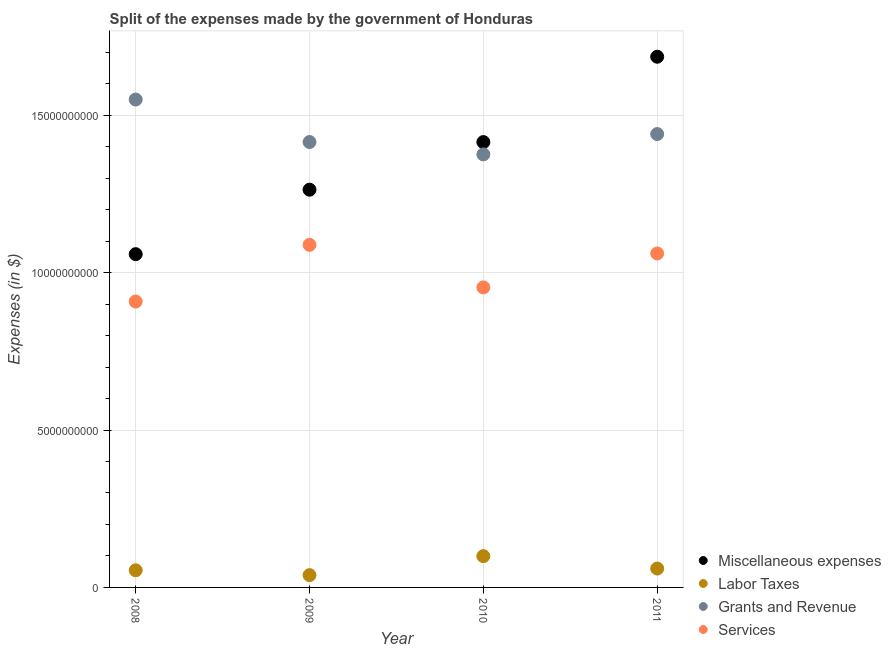How many different coloured dotlines are there?
Your response must be concise. 4. Is the number of dotlines equal to the number of legend labels?
Ensure brevity in your answer.  Yes. What is the amount spent on miscellaneous expenses in 2010?
Your answer should be compact. 1.41e+1. Across all years, what is the maximum amount spent on services?
Make the answer very short. 1.09e+1. Across all years, what is the minimum amount spent on grants and revenue?
Provide a short and direct response. 1.38e+1. What is the total amount spent on labor taxes in the graph?
Ensure brevity in your answer.  2.53e+09. What is the difference between the amount spent on miscellaneous expenses in 2010 and that in 2011?
Your answer should be compact. -2.71e+09. What is the difference between the amount spent on miscellaneous expenses in 2011 and the amount spent on grants and revenue in 2008?
Your response must be concise. 1.36e+09. What is the average amount spent on services per year?
Offer a very short reply. 1.00e+1. In the year 2008, what is the difference between the amount spent on services and amount spent on labor taxes?
Provide a short and direct response. 8.54e+09. In how many years, is the amount spent on labor taxes greater than 2000000000 $?
Your answer should be compact. 0. What is the ratio of the amount spent on grants and revenue in 2008 to that in 2010?
Your answer should be very brief. 1.13. Is the difference between the amount spent on labor taxes in 2009 and 2011 greater than the difference between the amount spent on services in 2009 and 2011?
Your answer should be compact. No. What is the difference between the highest and the second highest amount spent on miscellaneous expenses?
Provide a succinct answer. 2.71e+09. What is the difference between the highest and the lowest amount spent on labor taxes?
Provide a short and direct response. 6.03e+08. Does the amount spent on grants and revenue monotonically increase over the years?
Provide a succinct answer. No. How many dotlines are there?
Your answer should be very brief. 4. How many years are there in the graph?
Offer a terse response. 4. Are the values on the major ticks of Y-axis written in scientific E-notation?
Provide a short and direct response. No. How are the legend labels stacked?
Offer a very short reply. Vertical. What is the title of the graph?
Ensure brevity in your answer.  Split of the expenses made by the government of Honduras. Does "Social Assistance" appear as one of the legend labels in the graph?
Provide a short and direct response. No. What is the label or title of the X-axis?
Your answer should be very brief. Year. What is the label or title of the Y-axis?
Your response must be concise. Expenses (in $). What is the Expenses (in $) in Miscellaneous expenses in 2008?
Ensure brevity in your answer.  1.06e+1. What is the Expenses (in $) in Labor Taxes in 2008?
Keep it short and to the point. 5.44e+08. What is the Expenses (in $) in Grants and Revenue in 2008?
Ensure brevity in your answer.  1.55e+1. What is the Expenses (in $) in Services in 2008?
Give a very brief answer. 9.08e+09. What is the Expenses (in $) of Miscellaneous expenses in 2009?
Your response must be concise. 1.26e+1. What is the Expenses (in $) of Labor Taxes in 2009?
Give a very brief answer. 3.91e+08. What is the Expenses (in $) of Grants and Revenue in 2009?
Offer a very short reply. 1.41e+1. What is the Expenses (in $) of Services in 2009?
Provide a succinct answer. 1.09e+1. What is the Expenses (in $) in Miscellaneous expenses in 2010?
Make the answer very short. 1.41e+1. What is the Expenses (in $) in Labor Taxes in 2010?
Give a very brief answer. 9.94e+08. What is the Expenses (in $) in Grants and Revenue in 2010?
Ensure brevity in your answer.  1.38e+1. What is the Expenses (in $) in Services in 2010?
Your answer should be very brief. 9.53e+09. What is the Expenses (in $) in Miscellaneous expenses in 2011?
Offer a very short reply. 1.69e+1. What is the Expenses (in $) in Labor Taxes in 2011?
Your answer should be compact. 6.00e+08. What is the Expenses (in $) of Grants and Revenue in 2011?
Offer a terse response. 1.44e+1. What is the Expenses (in $) of Services in 2011?
Make the answer very short. 1.06e+1. Across all years, what is the maximum Expenses (in $) in Miscellaneous expenses?
Provide a succinct answer. 1.69e+1. Across all years, what is the maximum Expenses (in $) in Labor Taxes?
Keep it short and to the point. 9.94e+08. Across all years, what is the maximum Expenses (in $) of Grants and Revenue?
Your answer should be very brief. 1.55e+1. Across all years, what is the maximum Expenses (in $) of Services?
Provide a short and direct response. 1.09e+1. Across all years, what is the minimum Expenses (in $) of Miscellaneous expenses?
Your answer should be compact. 1.06e+1. Across all years, what is the minimum Expenses (in $) in Labor Taxes?
Your answer should be very brief. 3.91e+08. Across all years, what is the minimum Expenses (in $) of Grants and Revenue?
Offer a very short reply. 1.38e+1. Across all years, what is the minimum Expenses (in $) of Services?
Provide a short and direct response. 9.08e+09. What is the total Expenses (in $) of Miscellaneous expenses in the graph?
Provide a succinct answer. 5.42e+1. What is the total Expenses (in $) of Labor Taxes in the graph?
Offer a very short reply. 2.53e+09. What is the total Expenses (in $) in Grants and Revenue in the graph?
Provide a succinct answer. 5.78e+1. What is the total Expenses (in $) of Services in the graph?
Provide a succinct answer. 4.01e+1. What is the difference between the Expenses (in $) in Miscellaneous expenses in 2008 and that in 2009?
Offer a terse response. -2.05e+09. What is the difference between the Expenses (in $) of Labor Taxes in 2008 and that in 2009?
Provide a short and direct response. 1.53e+08. What is the difference between the Expenses (in $) of Grants and Revenue in 2008 and that in 2009?
Make the answer very short. 1.35e+09. What is the difference between the Expenses (in $) of Services in 2008 and that in 2009?
Your answer should be very brief. -1.80e+09. What is the difference between the Expenses (in $) of Miscellaneous expenses in 2008 and that in 2010?
Provide a succinct answer. -3.56e+09. What is the difference between the Expenses (in $) in Labor Taxes in 2008 and that in 2010?
Keep it short and to the point. -4.50e+08. What is the difference between the Expenses (in $) in Grants and Revenue in 2008 and that in 2010?
Provide a short and direct response. 1.74e+09. What is the difference between the Expenses (in $) of Services in 2008 and that in 2010?
Provide a short and direct response. -4.48e+08. What is the difference between the Expenses (in $) of Miscellaneous expenses in 2008 and that in 2011?
Offer a terse response. -6.27e+09. What is the difference between the Expenses (in $) in Labor Taxes in 2008 and that in 2011?
Give a very brief answer. -5.59e+07. What is the difference between the Expenses (in $) of Grants and Revenue in 2008 and that in 2011?
Keep it short and to the point. 1.10e+09. What is the difference between the Expenses (in $) of Services in 2008 and that in 2011?
Your answer should be compact. -1.53e+09. What is the difference between the Expenses (in $) in Miscellaneous expenses in 2009 and that in 2010?
Your response must be concise. -1.51e+09. What is the difference between the Expenses (in $) of Labor Taxes in 2009 and that in 2010?
Provide a short and direct response. -6.03e+08. What is the difference between the Expenses (in $) in Grants and Revenue in 2009 and that in 2010?
Provide a succinct answer. 3.92e+08. What is the difference between the Expenses (in $) of Services in 2009 and that in 2010?
Your response must be concise. 1.35e+09. What is the difference between the Expenses (in $) of Miscellaneous expenses in 2009 and that in 2011?
Offer a very short reply. -4.22e+09. What is the difference between the Expenses (in $) in Labor Taxes in 2009 and that in 2011?
Provide a short and direct response. -2.09e+08. What is the difference between the Expenses (in $) of Grants and Revenue in 2009 and that in 2011?
Offer a very short reply. -2.53e+08. What is the difference between the Expenses (in $) in Services in 2009 and that in 2011?
Offer a terse response. 2.73e+08. What is the difference between the Expenses (in $) of Miscellaneous expenses in 2010 and that in 2011?
Your answer should be very brief. -2.71e+09. What is the difference between the Expenses (in $) of Labor Taxes in 2010 and that in 2011?
Ensure brevity in your answer.  3.94e+08. What is the difference between the Expenses (in $) of Grants and Revenue in 2010 and that in 2011?
Give a very brief answer. -6.45e+08. What is the difference between the Expenses (in $) of Services in 2010 and that in 2011?
Make the answer very short. -1.08e+09. What is the difference between the Expenses (in $) of Miscellaneous expenses in 2008 and the Expenses (in $) of Labor Taxes in 2009?
Give a very brief answer. 1.02e+1. What is the difference between the Expenses (in $) in Miscellaneous expenses in 2008 and the Expenses (in $) in Grants and Revenue in 2009?
Your answer should be compact. -3.56e+09. What is the difference between the Expenses (in $) in Miscellaneous expenses in 2008 and the Expenses (in $) in Services in 2009?
Offer a terse response. -2.95e+08. What is the difference between the Expenses (in $) in Labor Taxes in 2008 and the Expenses (in $) in Grants and Revenue in 2009?
Give a very brief answer. -1.36e+1. What is the difference between the Expenses (in $) in Labor Taxes in 2008 and the Expenses (in $) in Services in 2009?
Your answer should be very brief. -1.03e+1. What is the difference between the Expenses (in $) of Grants and Revenue in 2008 and the Expenses (in $) of Services in 2009?
Your answer should be compact. 4.62e+09. What is the difference between the Expenses (in $) of Miscellaneous expenses in 2008 and the Expenses (in $) of Labor Taxes in 2010?
Provide a short and direct response. 9.59e+09. What is the difference between the Expenses (in $) in Miscellaneous expenses in 2008 and the Expenses (in $) in Grants and Revenue in 2010?
Make the answer very short. -3.17e+09. What is the difference between the Expenses (in $) of Miscellaneous expenses in 2008 and the Expenses (in $) of Services in 2010?
Offer a terse response. 1.06e+09. What is the difference between the Expenses (in $) in Labor Taxes in 2008 and the Expenses (in $) in Grants and Revenue in 2010?
Your response must be concise. -1.32e+1. What is the difference between the Expenses (in $) of Labor Taxes in 2008 and the Expenses (in $) of Services in 2010?
Provide a succinct answer. -8.99e+09. What is the difference between the Expenses (in $) in Grants and Revenue in 2008 and the Expenses (in $) in Services in 2010?
Your answer should be compact. 5.97e+09. What is the difference between the Expenses (in $) of Miscellaneous expenses in 2008 and the Expenses (in $) of Labor Taxes in 2011?
Keep it short and to the point. 9.99e+09. What is the difference between the Expenses (in $) of Miscellaneous expenses in 2008 and the Expenses (in $) of Grants and Revenue in 2011?
Provide a short and direct response. -3.81e+09. What is the difference between the Expenses (in $) of Miscellaneous expenses in 2008 and the Expenses (in $) of Services in 2011?
Make the answer very short. -2.27e+07. What is the difference between the Expenses (in $) in Labor Taxes in 2008 and the Expenses (in $) in Grants and Revenue in 2011?
Your answer should be compact. -1.39e+1. What is the difference between the Expenses (in $) in Labor Taxes in 2008 and the Expenses (in $) in Services in 2011?
Provide a succinct answer. -1.01e+1. What is the difference between the Expenses (in $) in Grants and Revenue in 2008 and the Expenses (in $) in Services in 2011?
Offer a very short reply. 4.89e+09. What is the difference between the Expenses (in $) of Miscellaneous expenses in 2009 and the Expenses (in $) of Labor Taxes in 2010?
Provide a short and direct response. 1.16e+1. What is the difference between the Expenses (in $) of Miscellaneous expenses in 2009 and the Expenses (in $) of Grants and Revenue in 2010?
Give a very brief answer. -1.12e+09. What is the difference between the Expenses (in $) in Miscellaneous expenses in 2009 and the Expenses (in $) in Services in 2010?
Your answer should be compact. 3.10e+09. What is the difference between the Expenses (in $) of Labor Taxes in 2009 and the Expenses (in $) of Grants and Revenue in 2010?
Provide a short and direct response. -1.34e+1. What is the difference between the Expenses (in $) of Labor Taxes in 2009 and the Expenses (in $) of Services in 2010?
Give a very brief answer. -9.14e+09. What is the difference between the Expenses (in $) of Grants and Revenue in 2009 and the Expenses (in $) of Services in 2010?
Offer a terse response. 4.62e+09. What is the difference between the Expenses (in $) of Miscellaneous expenses in 2009 and the Expenses (in $) of Labor Taxes in 2011?
Your answer should be very brief. 1.20e+1. What is the difference between the Expenses (in $) in Miscellaneous expenses in 2009 and the Expenses (in $) in Grants and Revenue in 2011?
Offer a very short reply. -1.77e+09. What is the difference between the Expenses (in $) of Miscellaneous expenses in 2009 and the Expenses (in $) of Services in 2011?
Provide a short and direct response. 2.02e+09. What is the difference between the Expenses (in $) of Labor Taxes in 2009 and the Expenses (in $) of Grants and Revenue in 2011?
Make the answer very short. -1.40e+1. What is the difference between the Expenses (in $) of Labor Taxes in 2009 and the Expenses (in $) of Services in 2011?
Ensure brevity in your answer.  -1.02e+1. What is the difference between the Expenses (in $) of Grants and Revenue in 2009 and the Expenses (in $) of Services in 2011?
Make the answer very short. 3.54e+09. What is the difference between the Expenses (in $) in Miscellaneous expenses in 2010 and the Expenses (in $) in Labor Taxes in 2011?
Provide a short and direct response. 1.35e+1. What is the difference between the Expenses (in $) in Miscellaneous expenses in 2010 and the Expenses (in $) in Grants and Revenue in 2011?
Your answer should be very brief. -2.55e+08. What is the difference between the Expenses (in $) in Miscellaneous expenses in 2010 and the Expenses (in $) in Services in 2011?
Ensure brevity in your answer.  3.54e+09. What is the difference between the Expenses (in $) in Labor Taxes in 2010 and the Expenses (in $) in Grants and Revenue in 2011?
Your response must be concise. -1.34e+1. What is the difference between the Expenses (in $) in Labor Taxes in 2010 and the Expenses (in $) in Services in 2011?
Provide a succinct answer. -9.61e+09. What is the difference between the Expenses (in $) of Grants and Revenue in 2010 and the Expenses (in $) of Services in 2011?
Make the answer very short. 3.15e+09. What is the average Expenses (in $) of Miscellaneous expenses per year?
Offer a very short reply. 1.36e+1. What is the average Expenses (in $) of Labor Taxes per year?
Make the answer very short. 6.32e+08. What is the average Expenses (in $) in Grants and Revenue per year?
Provide a short and direct response. 1.45e+1. What is the average Expenses (in $) in Services per year?
Your answer should be very brief. 1.00e+1. In the year 2008, what is the difference between the Expenses (in $) in Miscellaneous expenses and Expenses (in $) in Labor Taxes?
Give a very brief answer. 1.00e+1. In the year 2008, what is the difference between the Expenses (in $) in Miscellaneous expenses and Expenses (in $) in Grants and Revenue?
Ensure brevity in your answer.  -4.91e+09. In the year 2008, what is the difference between the Expenses (in $) of Miscellaneous expenses and Expenses (in $) of Services?
Keep it short and to the point. 1.50e+09. In the year 2008, what is the difference between the Expenses (in $) in Labor Taxes and Expenses (in $) in Grants and Revenue?
Your response must be concise. -1.50e+1. In the year 2008, what is the difference between the Expenses (in $) of Labor Taxes and Expenses (in $) of Services?
Give a very brief answer. -8.54e+09. In the year 2008, what is the difference between the Expenses (in $) of Grants and Revenue and Expenses (in $) of Services?
Offer a very short reply. 6.42e+09. In the year 2009, what is the difference between the Expenses (in $) in Miscellaneous expenses and Expenses (in $) in Labor Taxes?
Provide a succinct answer. 1.22e+1. In the year 2009, what is the difference between the Expenses (in $) of Miscellaneous expenses and Expenses (in $) of Grants and Revenue?
Keep it short and to the point. -1.51e+09. In the year 2009, what is the difference between the Expenses (in $) in Miscellaneous expenses and Expenses (in $) in Services?
Keep it short and to the point. 1.75e+09. In the year 2009, what is the difference between the Expenses (in $) in Labor Taxes and Expenses (in $) in Grants and Revenue?
Give a very brief answer. -1.38e+1. In the year 2009, what is the difference between the Expenses (in $) of Labor Taxes and Expenses (in $) of Services?
Ensure brevity in your answer.  -1.05e+1. In the year 2009, what is the difference between the Expenses (in $) in Grants and Revenue and Expenses (in $) in Services?
Keep it short and to the point. 3.27e+09. In the year 2010, what is the difference between the Expenses (in $) in Miscellaneous expenses and Expenses (in $) in Labor Taxes?
Your response must be concise. 1.32e+1. In the year 2010, what is the difference between the Expenses (in $) in Miscellaneous expenses and Expenses (in $) in Grants and Revenue?
Offer a terse response. 3.90e+08. In the year 2010, what is the difference between the Expenses (in $) in Miscellaneous expenses and Expenses (in $) in Services?
Your response must be concise. 4.62e+09. In the year 2010, what is the difference between the Expenses (in $) in Labor Taxes and Expenses (in $) in Grants and Revenue?
Ensure brevity in your answer.  -1.28e+1. In the year 2010, what is the difference between the Expenses (in $) in Labor Taxes and Expenses (in $) in Services?
Ensure brevity in your answer.  -8.54e+09. In the year 2010, what is the difference between the Expenses (in $) of Grants and Revenue and Expenses (in $) of Services?
Ensure brevity in your answer.  4.23e+09. In the year 2011, what is the difference between the Expenses (in $) in Miscellaneous expenses and Expenses (in $) in Labor Taxes?
Provide a short and direct response. 1.63e+1. In the year 2011, what is the difference between the Expenses (in $) of Miscellaneous expenses and Expenses (in $) of Grants and Revenue?
Give a very brief answer. 2.46e+09. In the year 2011, what is the difference between the Expenses (in $) of Miscellaneous expenses and Expenses (in $) of Services?
Offer a terse response. 6.25e+09. In the year 2011, what is the difference between the Expenses (in $) in Labor Taxes and Expenses (in $) in Grants and Revenue?
Provide a succinct answer. -1.38e+1. In the year 2011, what is the difference between the Expenses (in $) of Labor Taxes and Expenses (in $) of Services?
Give a very brief answer. -1.00e+1. In the year 2011, what is the difference between the Expenses (in $) of Grants and Revenue and Expenses (in $) of Services?
Your response must be concise. 3.79e+09. What is the ratio of the Expenses (in $) of Miscellaneous expenses in 2008 to that in 2009?
Ensure brevity in your answer.  0.84. What is the ratio of the Expenses (in $) of Labor Taxes in 2008 to that in 2009?
Keep it short and to the point. 1.39. What is the ratio of the Expenses (in $) of Grants and Revenue in 2008 to that in 2009?
Your answer should be very brief. 1.1. What is the ratio of the Expenses (in $) in Services in 2008 to that in 2009?
Your answer should be compact. 0.83. What is the ratio of the Expenses (in $) of Miscellaneous expenses in 2008 to that in 2010?
Provide a succinct answer. 0.75. What is the ratio of the Expenses (in $) in Labor Taxes in 2008 to that in 2010?
Your response must be concise. 0.55. What is the ratio of the Expenses (in $) in Grants and Revenue in 2008 to that in 2010?
Offer a very short reply. 1.13. What is the ratio of the Expenses (in $) in Services in 2008 to that in 2010?
Your answer should be very brief. 0.95. What is the ratio of the Expenses (in $) in Miscellaneous expenses in 2008 to that in 2011?
Your answer should be very brief. 0.63. What is the ratio of the Expenses (in $) in Labor Taxes in 2008 to that in 2011?
Your response must be concise. 0.91. What is the ratio of the Expenses (in $) in Grants and Revenue in 2008 to that in 2011?
Make the answer very short. 1.08. What is the ratio of the Expenses (in $) of Services in 2008 to that in 2011?
Offer a very short reply. 0.86. What is the ratio of the Expenses (in $) of Miscellaneous expenses in 2009 to that in 2010?
Your answer should be very brief. 0.89. What is the ratio of the Expenses (in $) in Labor Taxes in 2009 to that in 2010?
Offer a very short reply. 0.39. What is the ratio of the Expenses (in $) in Grants and Revenue in 2009 to that in 2010?
Provide a succinct answer. 1.03. What is the ratio of the Expenses (in $) of Services in 2009 to that in 2010?
Make the answer very short. 1.14. What is the ratio of the Expenses (in $) in Miscellaneous expenses in 2009 to that in 2011?
Ensure brevity in your answer.  0.75. What is the ratio of the Expenses (in $) of Labor Taxes in 2009 to that in 2011?
Provide a succinct answer. 0.65. What is the ratio of the Expenses (in $) of Grants and Revenue in 2009 to that in 2011?
Offer a very short reply. 0.98. What is the ratio of the Expenses (in $) in Services in 2009 to that in 2011?
Provide a succinct answer. 1.03. What is the ratio of the Expenses (in $) of Miscellaneous expenses in 2010 to that in 2011?
Provide a succinct answer. 0.84. What is the ratio of the Expenses (in $) of Labor Taxes in 2010 to that in 2011?
Your answer should be compact. 1.66. What is the ratio of the Expenses (in $) in Grants and Revenue in 2010 to that in 2011?
Make the answer very short. 0.96. What is the ratio of the Expenses (in $) of Services in 2010 to that in 2011?
Offer a very short reply. 0.9. What is the difference between the highest and the second highest Expenses (in $) in Miscellaneous expenses?
Keep it short and to the point. 2.71e+09. What is the difference between the highest and the second highest Expenses (in $) of Labor Taxes?
Offer a very short reply. 3.94e+08. What is the difference between the highest and the second highest Expenses (in $) of Grants and Revenue?
Your answer should be very brief. 1.10e+09. What is the difference between the highest and the second highest Expenses (in $) in Services?
Your answer should be very brief. 2.73e+08. What is the difference between the highest and the lowest Expenses (in $) in Miscellaneous expenses?
Keep it short and to the point. 6.27e+09. What is the difference between the highest and the lowest Expenses (in $) of Labor Taxes?
Keep it short and to the point. 6.03e+08. What is the difference between the highest and the lowest Expenses (in $) of Grants and Revenue?
Provide a short and direct response. 1.74e+09. What is the difference between the highest and the lowest Expenses (in $) of Services?
Offer a very short reply. 1.80e+09. 